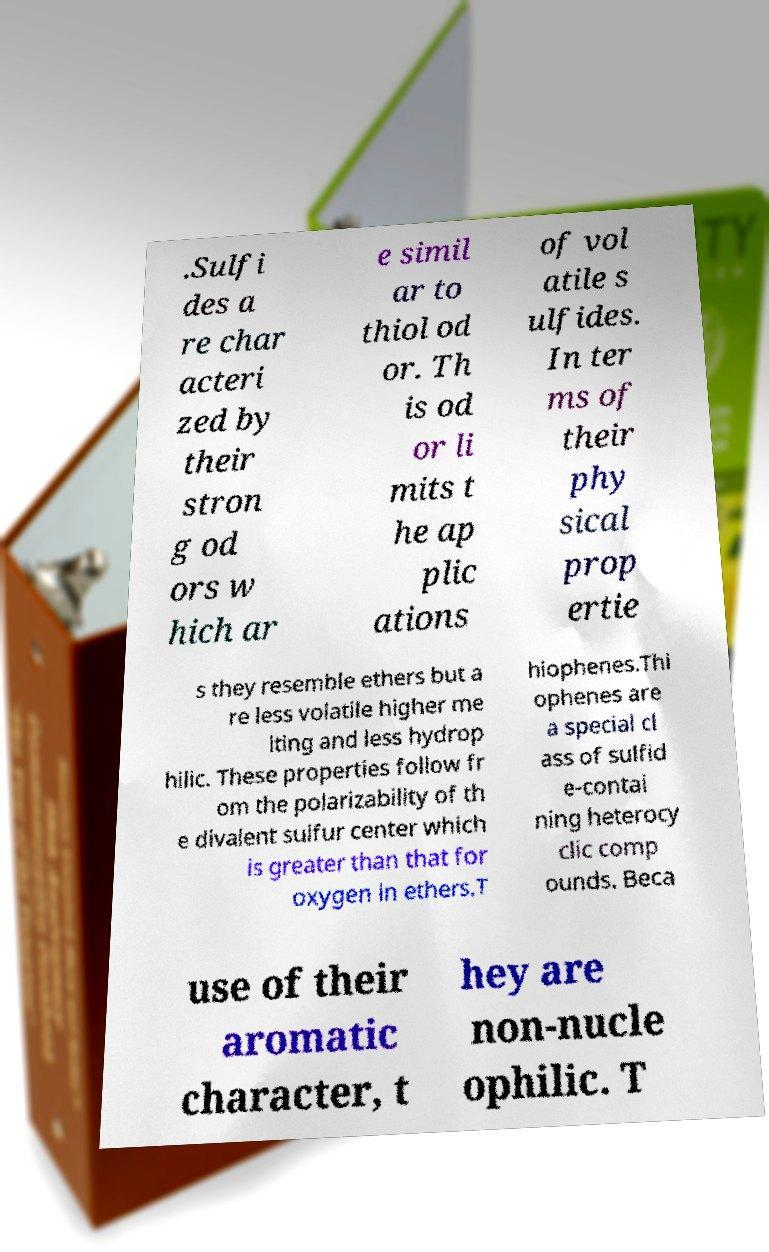Could you extract and type out the text from this image? .Sulfi des a re char acteri zed by their stron g od ors w hich ar e simil ar to thiol od or. Th is od or li mits t he ap plic ations of vol atile s ulfides. In ter ms of their phy sical prop ertie s they resemble ethers but a re less volatile higher me lting and less hydrop hilic. These properties follow fr om the polarizability of th e divalent sulfur center which is greater than that for oxygen in ethers.T hiophenes.Thi ophenes are a special cl ass of sulfid e-contai ning heterocy clic comp ounds. Beca use of their aromatic character, t hey are non-nucle ophilic. T 